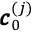<formula> <loc_0><loc_0><loc_500><loc_500>\pm b { c } _ { 0 } ^ { ( j ) }</formula> 